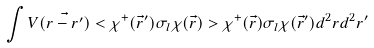<formula> <loc_0><loc_0><loc_500><loc_500>\int V ( \vec { r - r ^ { \prime } } ) < \chi ^ { + } ( \vec { r } ^ { \prime } ) \sigma _ { l } \chi ( \vec { r } ) > \chi ^ { + } ( \vec { r } ) \sigma _ { l } \chi ( \vec { r } ^ { \prime } ) d ^ { 2 } r d ^ { 2 } r ^ { \prime }</formula> 